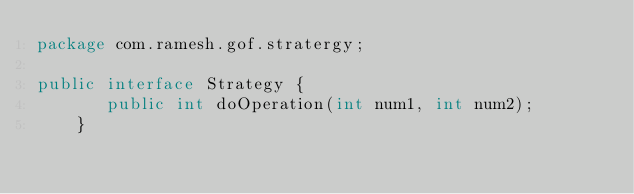Convert code to text. <code><loc_0><loc_0><loc_500><loc_500><_Java_>package com.ramesh.gof.stratergy;

public interface Strategy {
	   public int doOperation(int num1, int num2);
	}
</code> 